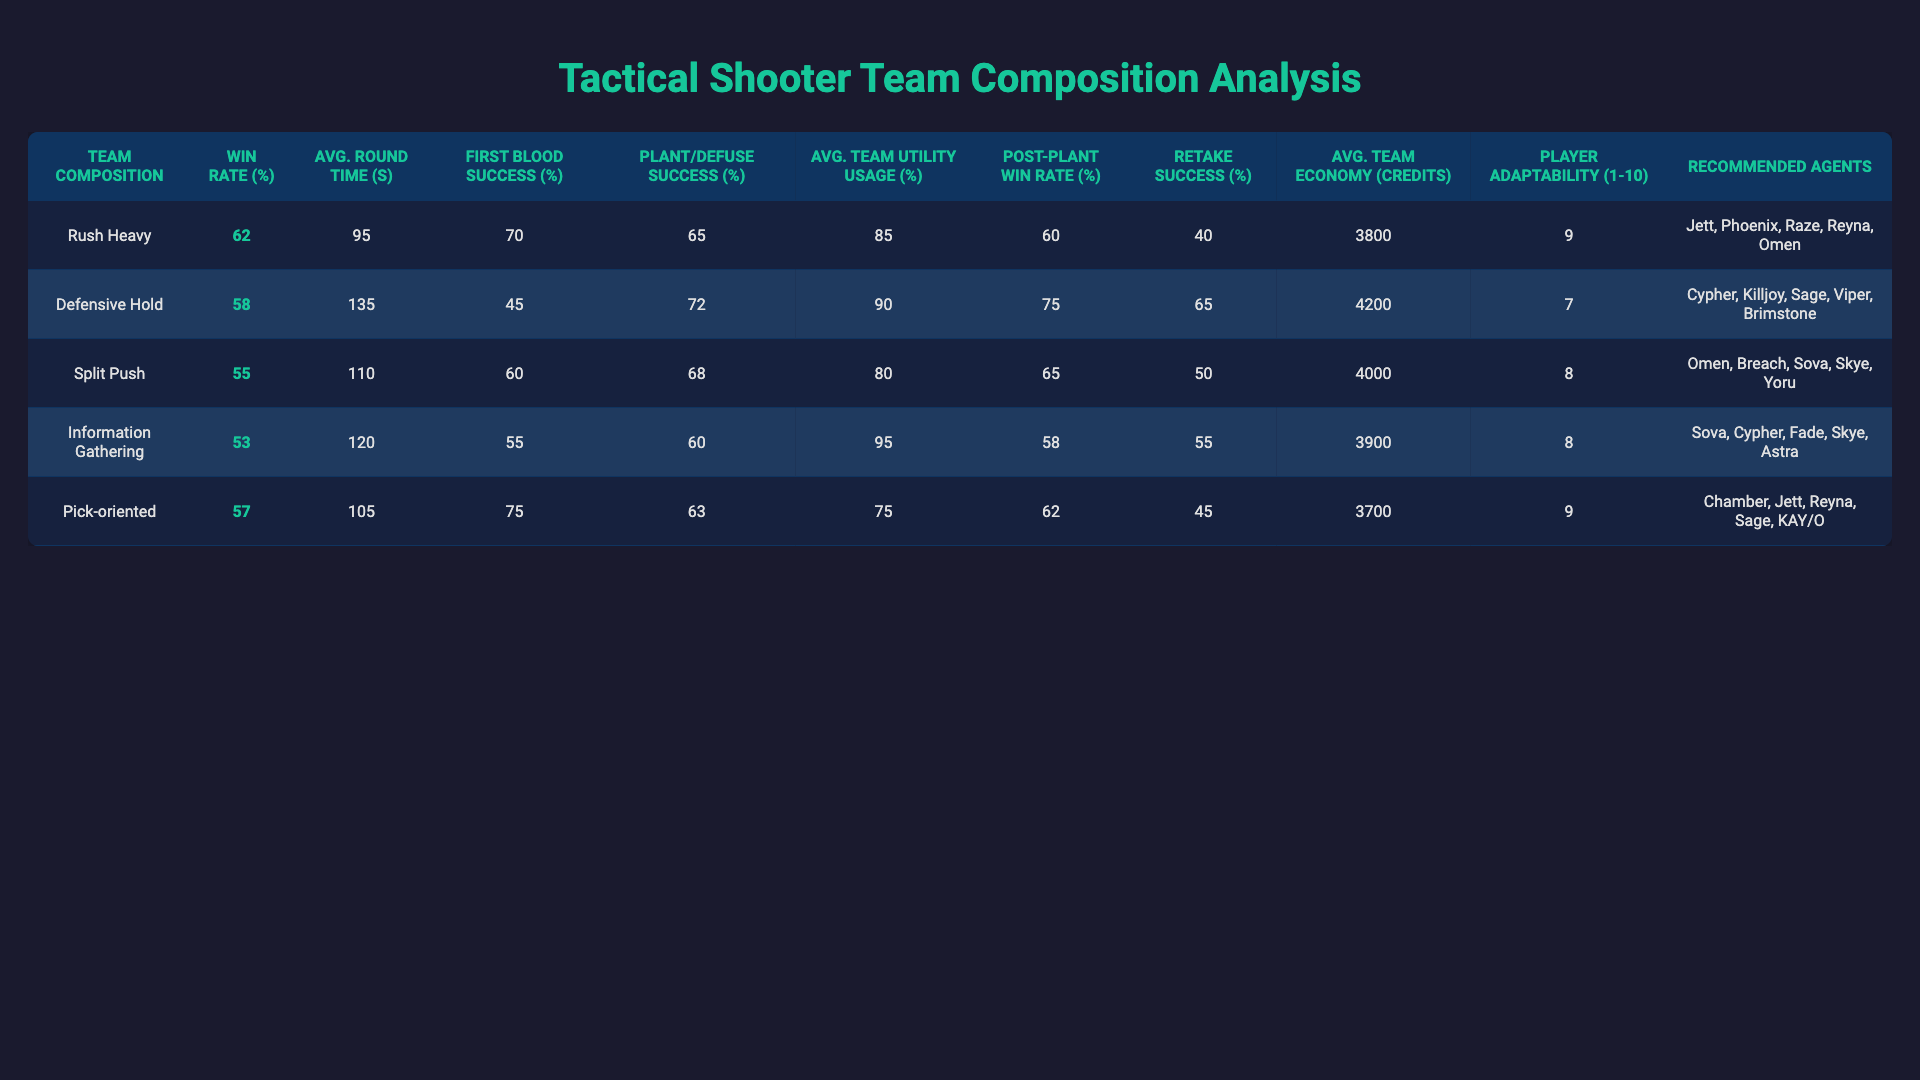What is the win rate of the "Rush Heavy" team composition? The table lists the win rates for each team composition, and "Rush Heavy" has a win rate of 62%.
Answer: 62% Which team composition has the highest average round time? In the table, "Defensive Hold" has the highest average round time of 135 seconds compared to the others.
Answer: Defensive Hold What is the difference in First Blood Success Rate between "Pick-oriented" and "Defensive Hold"? The First Blood Success Rate of "Pick-oriented" is 75%, and for "Defensive Hold" it is 45%. The difference is 75% - 45% = 30%.
Answer: 30% True or False: "Information Gathering" has a higher Plant/Defuse Success Rate than "Pick-oriented." "Information Gathering" has a Plant/Defuse Success Rate of 60% while "Pick-oriented" has 63%, which means the statement is false.
Answer: False What is the average Player Adaptability Score for the team compositions? To find the average, sum all the Player Adaptability Scores (9 + 7 + 8 + 8 + 9 = 41) and divide by the number of compositions (5), which gives an average of 41 / 5 = 8.2.
Answer: 8.2 Which team composition has the highest Post-Plant Win Rate, and what is that rate? Looking at the table, "Defensive Hold" has the highest Post-Plant Win Rate, recorded at 75%.
Answer: Defensive Hold, 75% If you combine the Average Round Time of "Split Push" and "Pick-oriented," what is the total? "Split Push" has an average round time of 110 seconds and "Pick-oriented" has 105 seconds. Adding these gives 110 + 105 = 215 seconds.
Answer: 215 seconds Which composition has the lowest Retake Success Rate? Among the Retake Success Rates listed, "Rush Heavy" has the lowest at 40%.
Answer: Rush Heavy If a team uses the "Defensive Hold" composition, how much more team utility are they using compared to "Pick-oriented"? "Defensive Hold" uses 90% of team utility, while "Pick-oriented" uses 75%. The difference is 90% - 75% = 15%.
Answer: 15% Identify the team composition with the lowest Average Team Economy. What is the amount? "Pick-oriented" has the lowest Average Team Economy with 3700 credits.
Answer: Pick-oriented, 3700 credits 